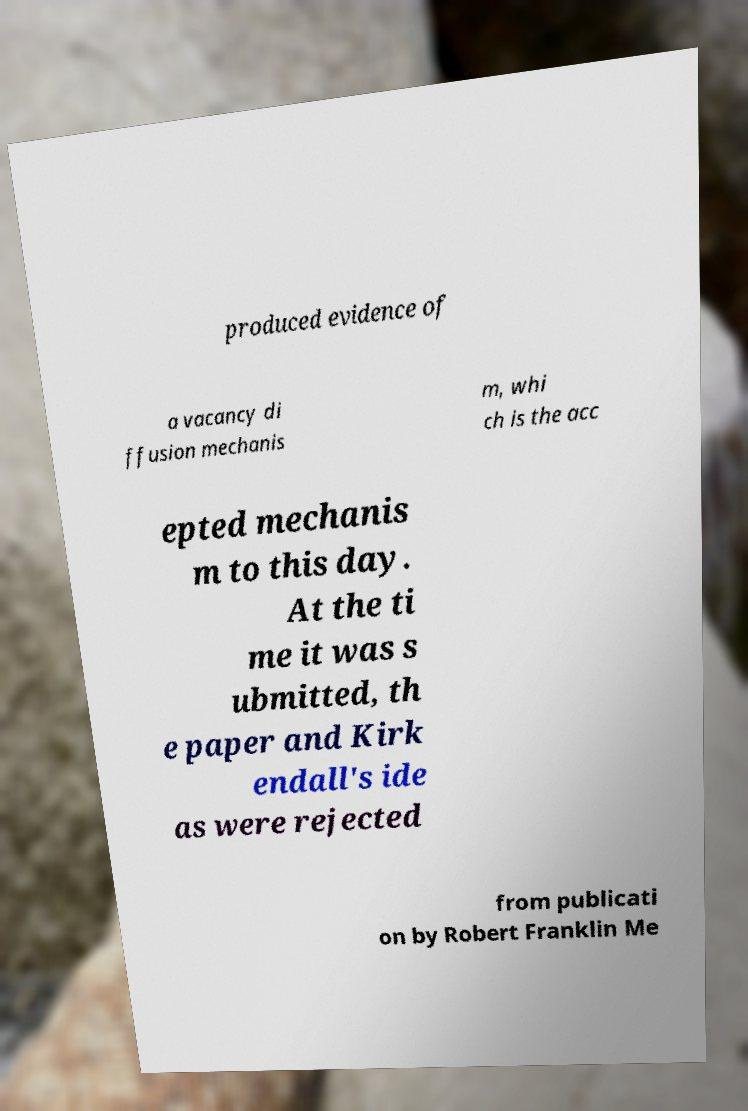There's text embedded in this image that I need extracted. Can you transcribe it verbatim? produced evidence of a vacancy di ffusion mechanis m, whi ch is the acc epted mechanis m to this day. At the ti me it was s ubmitted, th e paper and Kirk endall's ide as were rejected from publicati on by Robert Franklin Me 